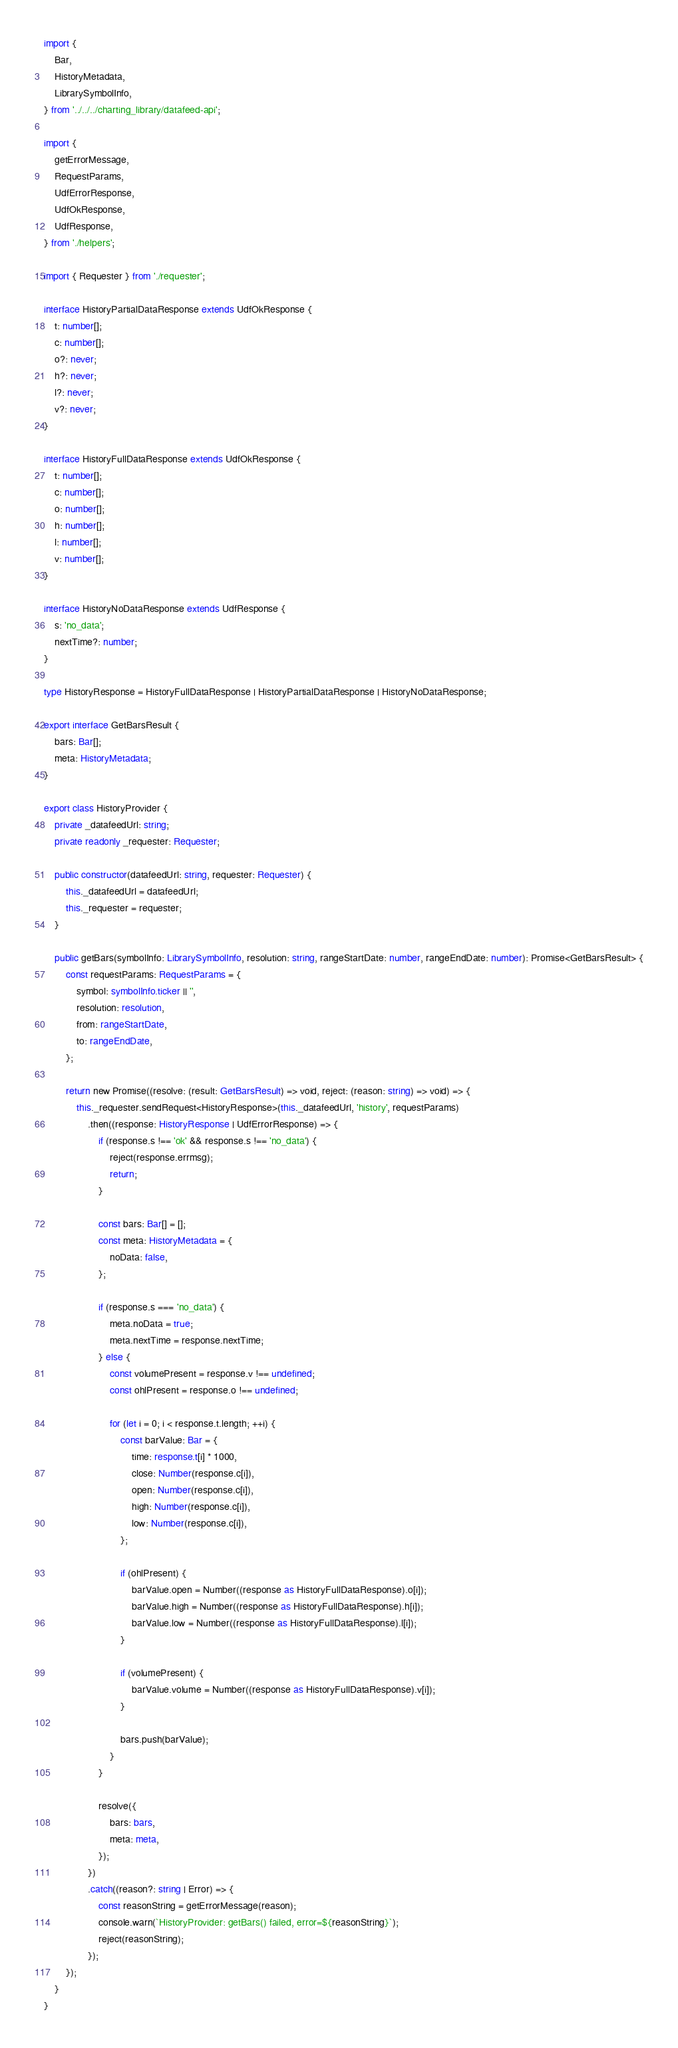Convert code to text. <code><loc_0><loc_0><loc_500><loc_500><_TypeScript_>import {
	Bar,
	HistoryMetadata,
	LibrarySymbolInfo,
} from '../../../charting_library/datafeed-api';

import {
	getErrorMessage,
	RequestParams,
	UdfErrorResponse,
	UdfOkResponse,
	UdfResponse,
} from './helpers';

import { Requester } from './requester';

interface HistoryPartialDataResponse extends UdfOkResponse {
	t: number[];
	c: number[];
	o?: never;
	h?: never;
	l?: never;
	v?: never;
}

interface HistoryFullDataResponse extends UdfOkResponse {
	t: number[];
	c: number[];
	o: number[];
	h: number[];
	l: number[];
	v: number[];
}

interface HistoryNoDataResponse extends UdfResponse {
	s: 'no_data';
	nextTime?: number;
}

type HistoryResponse = HistoryFullDataResponse | HistoryPartialDataResponse | HistoryNoDataResponse;

export interface GetBarsResult {
	bars: Bar[];
	meta: HistoryMetadata;
}

export class HistoryProvider {
	private _datafeedUrl: string;
	private readonly _requester: Requester;

	public constructor(datafeedUrl: string, requester: Requester) {
		this._datafeedUrl = datafeedUrl;
		this._requester = requester;
	}

	public getBars(symbolInfo: LibrarySymbolInfo, resolution: string, rangeStartDate: number, rangeEndDate: number): Promise<GetBarsResult> {
		const requestParams: RequestParams = {
			symbol: symbolInfo.ticker || '',
			resolution: resolution,
			from: rangeStartDate,
			to: rangeEndDate,
		};

		return new Promise((resolve: (result: GetBarsResult) => void, reject: (reason: string) => void) => {
			this._requester.sendRequest<HistoryResponse>(this._datafeedUrl, 'history', requestParams)
				.then((response: HistoryResponse | UdfErrorResponse) => {
					if (response.s !== 'ok' && response.s !== 'no_data') {
						reject(response.errmsg);
						return;
					}

					const bars: Bar[] = [];
					const meta: HistoryMetadata = {
						noData: false,
					};

					if (response.s === 'no_data') {
						meta.noData = true;
						meta.nextTime = response.nextTime;
					} else {
						const volumePresent = response.v !== undefined;
						const ohlPresent = response.o !== undefined;

						for (let i = 0; i < response.t.length; ++i) {
							const barValue: Bar = {
								time: response.t[i] * 1000,
								close: Number(response.c[i]),
								open: Number(response.c[i]),
								high: Number(response.c[i]),
								low: Number(response.c[i]),
							};

							if (ohlPresent) {
								barValue.open = Number((response as HistoryFullDataResponse).o[i]);
								barValue.high = Number((response as HistoryFullDataResponse).h[i]);
								barValue.low = Number((response as HistoryFullDataResponse).l[i]);
							}

							if (volumePresent) {
								barValue.volume = Number((response as HistoryFullDataResponse).v[i]);
							}

							bars.push(barValue);
						}
					}

					resolve({
						bars: bars,
						meta: meta,
					});
				})
				.catch((reason?: string | Error) => {
					const reasonString = getErrorMessage(reason);
					console.warn(`HistoryProvider: getBars() failed, error=${reasonString}`);
					reject(reasonString);
				});
		});
	}
}
</code> 